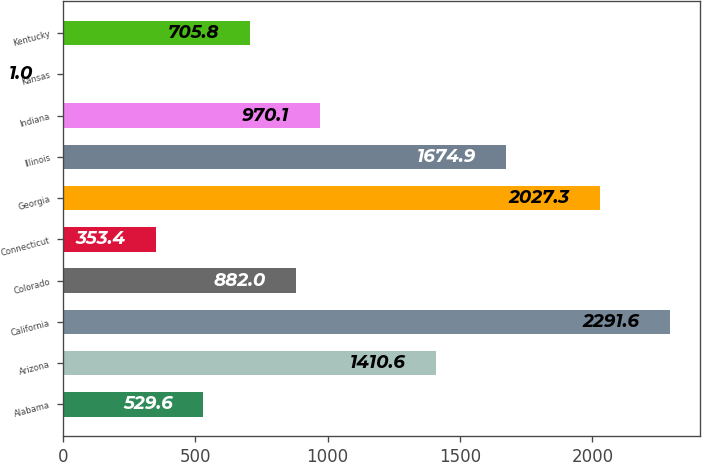Convert chart. <chart><loc_0><loc_0><loc_500><loc_500><bar_chart><fcel>Alabama<fcel>Arizona<fcel>California<fcel>Colorado<fcel>Connecticut<fcel>Georgia<fcel>Illinois<fcel>Indiana<fcel>Kansas<fcel>Kentucky<nl><fcel>529.6<fcel>1410.6<fcel>2291.6<fcel>882<fcel>353.4<fcel>2027.3<fcel>1674.9<fcel>970.1<fcel>1<fcel>705.8<nl></chart> 